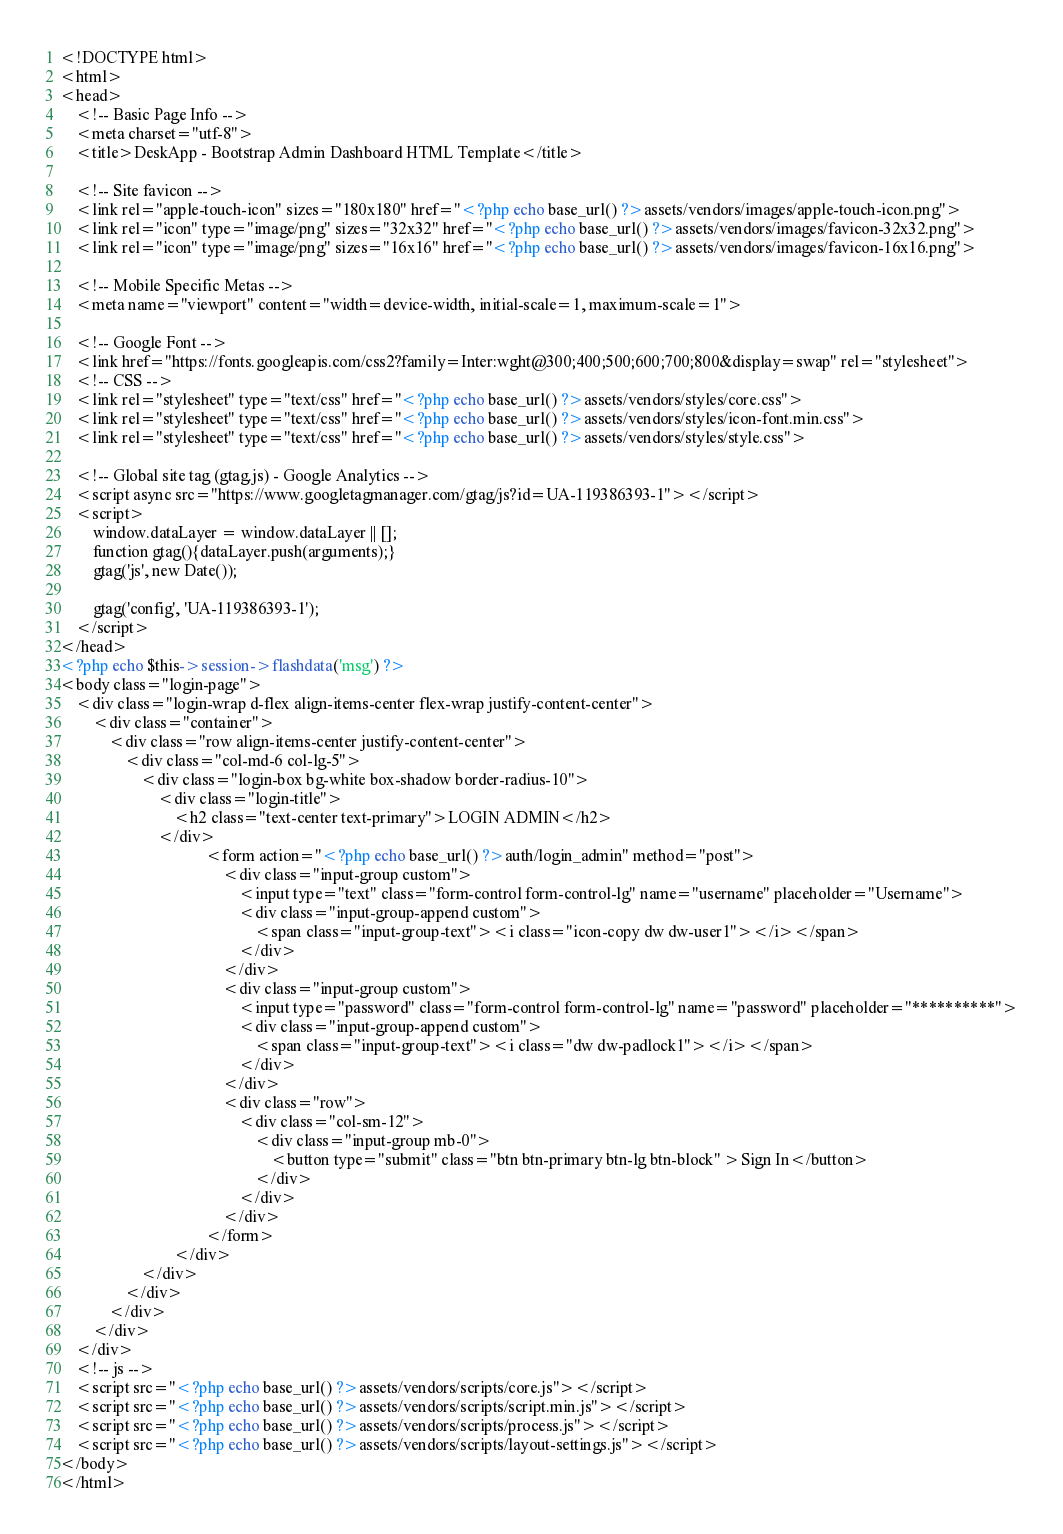Convert code to text. <code><loc_0><loc_0><loc_500><loc_500><_PHP_><!DOCTYPE html>
<html>
<head>
	<!-- Basic Page Info -->
	<meta charset="utf-8">
	<title>DeskApp - Bootstrap Admin Dashboard HTML Template</title>

	<!-- Site favicon -->
	<link rel="apple-touch-icon" sizes="180x180" href="<?php echo base_url() ?>assets/vendors/images/apple-touch-icon.png">
	<link rel="icon" type="image/png" sizes="32x32" href="<?php echo base_url() ?>assets/vendors/images/favicon-32x32.png">
	<link rel="icon" type="image/png" sizes="16x16" href="<?php echo base_url() ?>assets/vendors/images/favicon-16x16.png">

	<!-- Mobile Specific Metas -->
	<meta name="viewport" content="width=device-width, initial-scale=1, maximum-scale=1">

	<!-- Google Font -->
	<link href="https://fonts.googleapis.com/css2?family=Inter:wght@300;400;500;600;700;800&display=swap" rel="stylesheet">
	<!-- CSS -->
	<link rel="stylesheet" type="text/css" href="<?php echo base_url() ?>assets/vendors/styles/core.css">
	<link rel="stylesheet" type="text/css" href="<?php echo base_url() ?>assets/vendors/styles/icon-font.min.css">
	<link rel="stylesheet" type="text/css" href="<?php echo base_url() ?>assets/vendors/styles/style.css">

	<!-- Global site tag (gtag.js) - Google Analytics -->
	<script async src="https://www.googletagmanager.com/gtag/js?id=UA-119386393-1"></script>
	<script>
		window.dataLayer = window.dataLayer || [];
		function gtag(){dataLayer.push(arguments);}
		gtag('js', new Date());

		gtag('config', 'UA-119386393-1');
	</script>
</head>
<?php echo $this->session->flashdata('msg') ?>
<body class="login-page">
	<div class="login-wrap d-flex align-items-center flex-wrap justify-content-center">
		<div class="container">
			<div class="row align-items-center justify-content-center">
				<div class="col-md-6 col-lg-5">
					<div class="login-box bg-white box-shadow border-radius-10">
						<div class="login-title">
							<h2 class="text-center text-primary">LOGIN ADMIN</h2>
						</div>
									<form action="<?php echo base_url() ?>auth/login_admin" method="post">
										<div class="input-group custom">
											<input type="text" class="form-control form-control-lg" name="username" placeholder="Username">
											<div class="input-group-append custom">
												<span class="input-group-text"><i class="icon-copy dw dw-user1"></i></span>
											</div>
										</div>
										<div class="input-group custom">
											<input type="password" class="form-control form-control-lg" name="password" placeholder="**********">
											<div class="input-group-append custom">
												<span class="input-group-text"><i class="dw dw-padlock1"></i></span>
											</div>
										</div>
										<div class="row">
											<div class="col-sm-12">
												<div class="input-group mb-0">
													<button type="submit" class="btn btn-primary btn-lg btn-block" >Sign In</button>
												</div>
											</div>
										</div>
									</form>
							</div>
					</div>
				</div>
			</div>
		</div>
	</div>
	<!-- js -->
	<script src="<?php echo base_url() ?>assets/vendors/scripts/core.js"></script>
	<script src="<?php echo base_url() ?>assets/vendors/scripts/script.min.js"></script>
	<script src="<?php echo base_url() ?>assets/vendors/scripts/process.js"></script>
	<script src="<?php echo base_url() ?>assets/vendors/scripts/layout-settings.js"></script>
</body>
</html></code> 